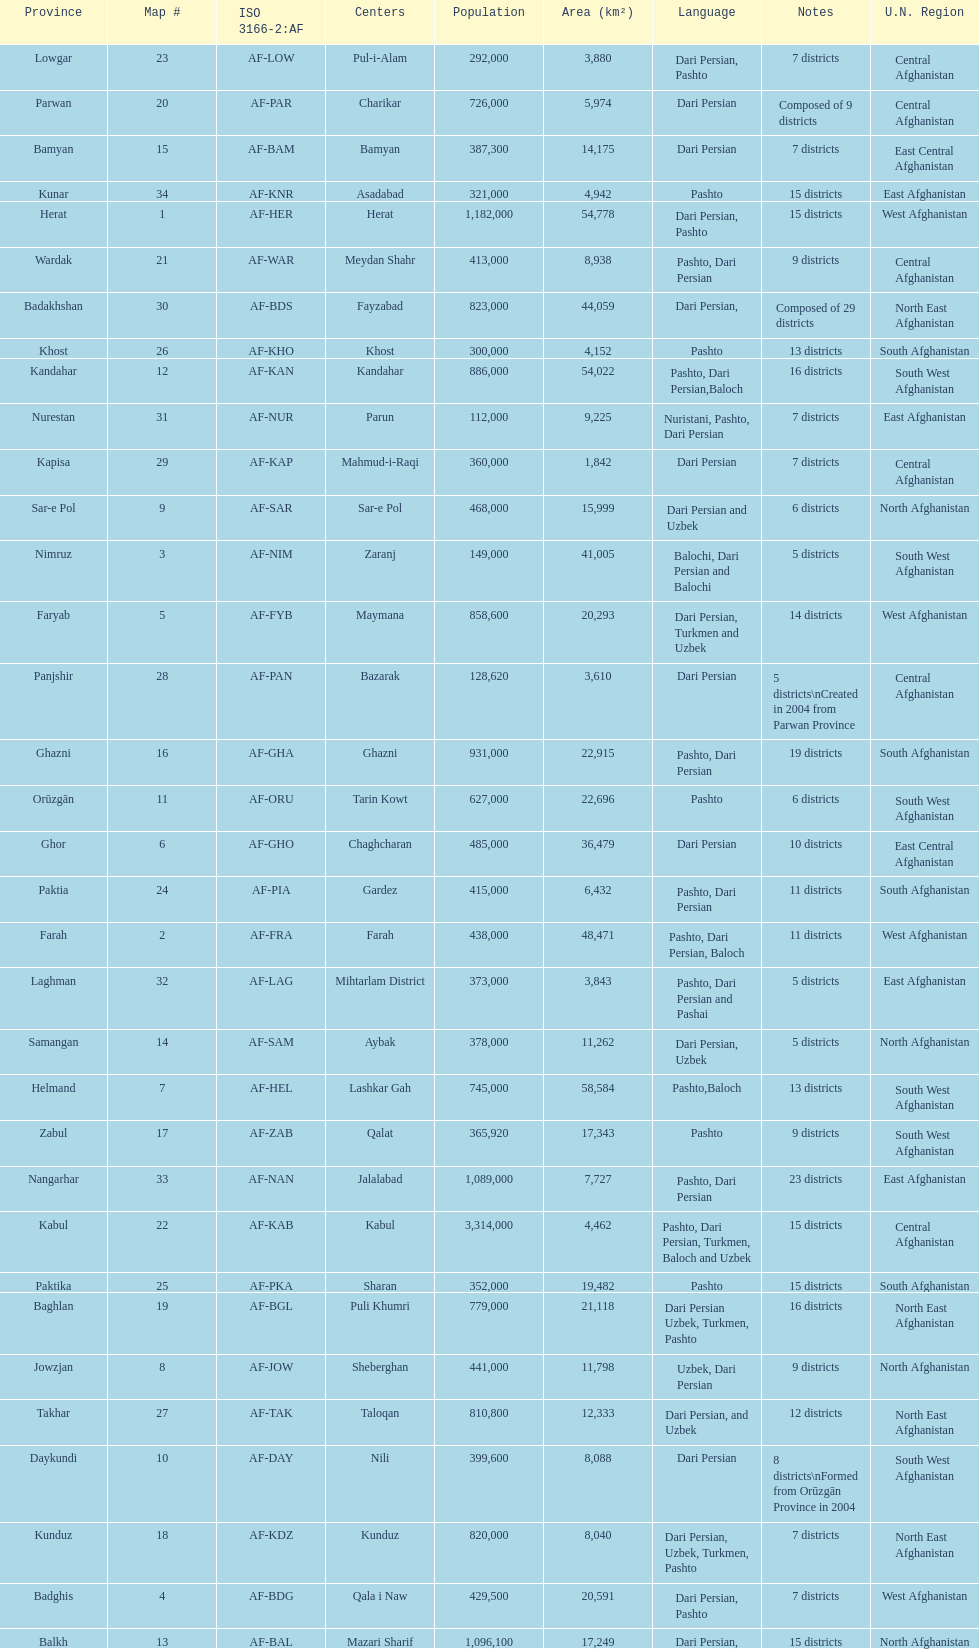How many provinces have pashto as one of their languages 20. 